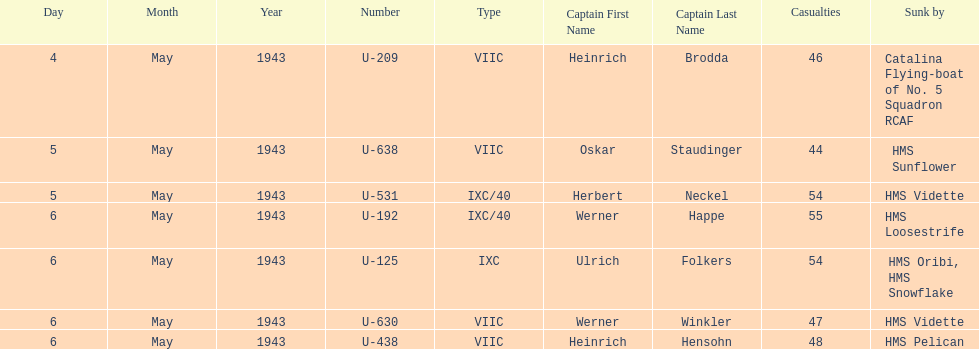How many captains are listed? 7. 